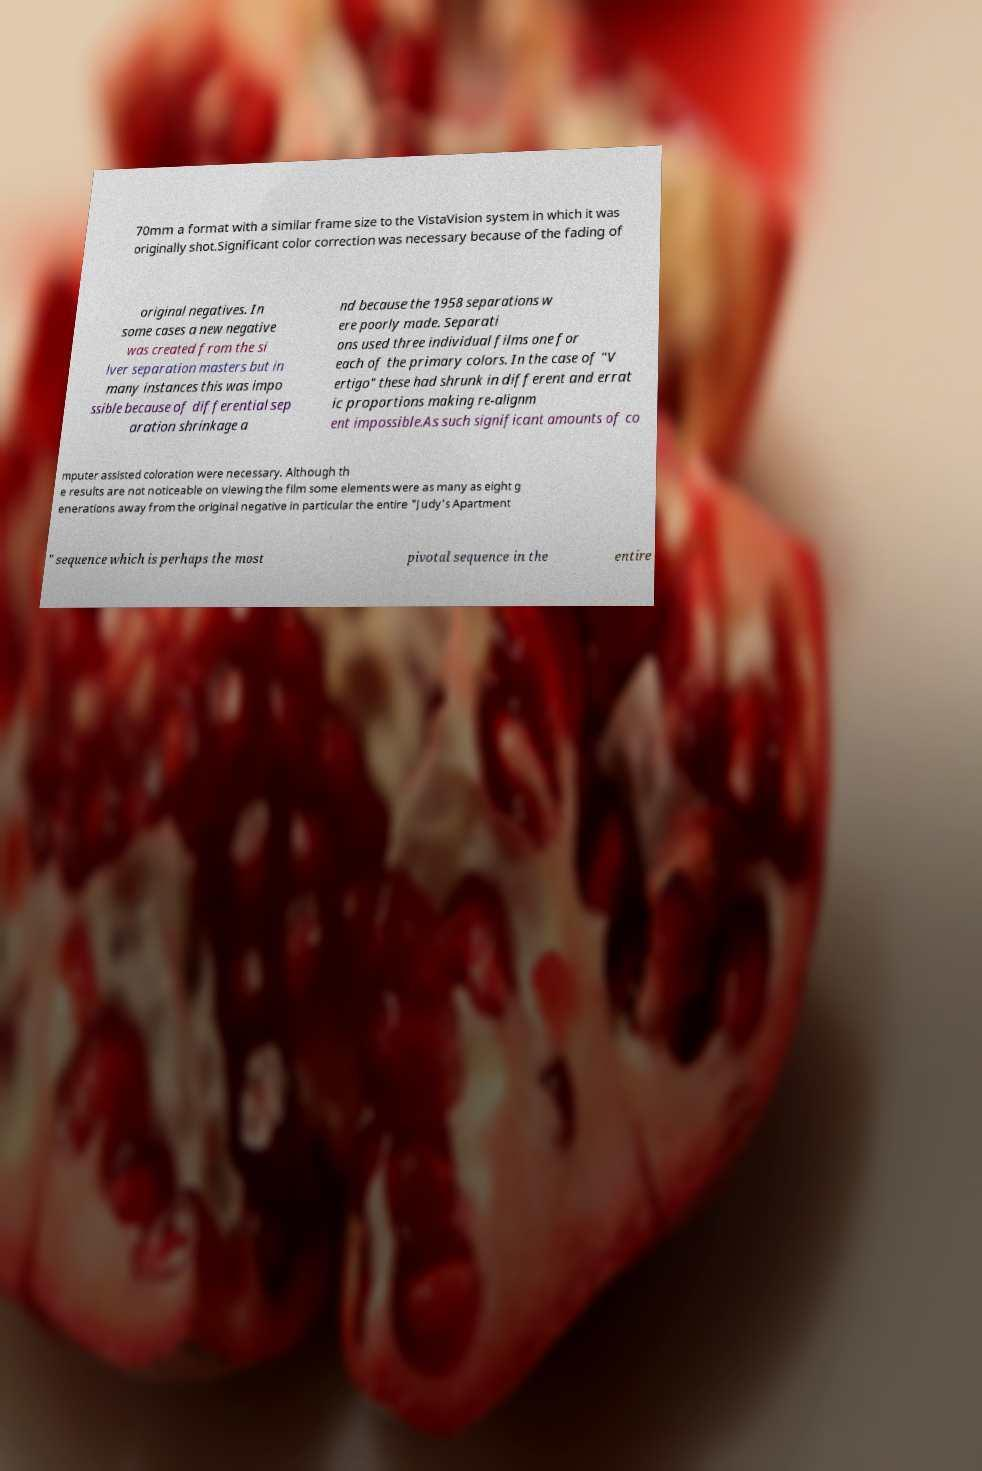Can you accurately transcribe the text from the provided image for me? 70mm a format with a similar frame size to the VistaVision system in which it was originally shot.Significant color correction was necessary because of the fading of original negatives. In some cases a new negative was created from the si lver separation masters but in many instances this was impo ssible because of differential sep aration shrinkage a nd because the 1958 separations w ere poorly made. Separati ons used three individual films one for each of the primary colors. In the case of "V ertigo" these had shrunk in different and errat ic proportions making re-alignm ent impossible.As such significant amounts of co mputer assisted coloration were necessary. Although th e results are not noticeable on viewing the film some elements were as many as eight g enerations away from the original negative in particular the entire "Judy's Apartment " sequence which is perhaps the most pivotal sequence in the entire 